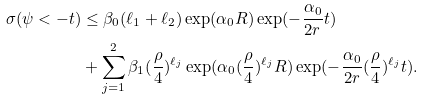Convert formula to latex. <formula><loc_0><loc_0><loc_500><loc_500>\sigma ( \psi < - t ) & \leq \beta _ { 0 } ( \ell _ { 1 } + \ell _ { 2 } ) \exp ( \alpha _ { 0 } R ) \exp ( - \frac { \alpha _ { 0 } } { 2 r } t ) \\ & + \sum _ { j = 1 } ^ { 2 } \beta _ { 1 } ( \frac { \rho } { 4 } ) ^ { \ell _ { j } } \exp ( \alpha _ { 0 } ( \frac { \rho } { 4 } ) ^ { \ell _ { j } } R ) \exp ( - \frac { \alpha _ { 0 } } { 2 r } ( \frac { \rho } { 4 } ) ^ { \ell _ { j } } t ) . \\</formula> 